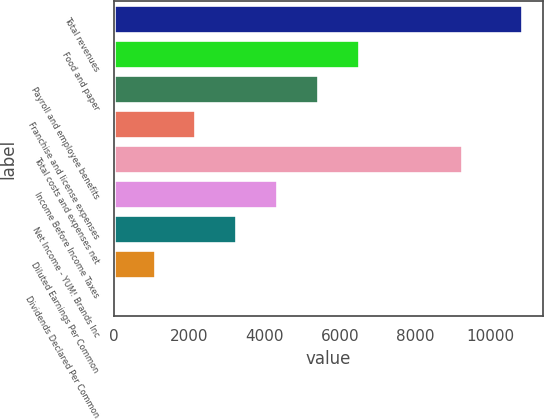Convert chart. <chart><loc_0><loc_0><loc_500><loc_500><bar_chart><fcel>Total revenues<fcel>Food and paper<fcel>Payroll and employee benefits<fcel>Franchise and license expenses<fcel>Total costs and expenses net<fcel>Income Before Income Taxes<fcel>Net Income - YUM! Brands Inc<fcel>Diluted Earnings Per Common<fcel>Dividends Declared Per Common<nl><fcel>10836<fcel>6501.92<fcel>5418.4<fcel>2167.84<fcel>9246<fcel>4334.88<fcel>3251.36<fcel>1084.32<fcel>0.8<nl></chart> 